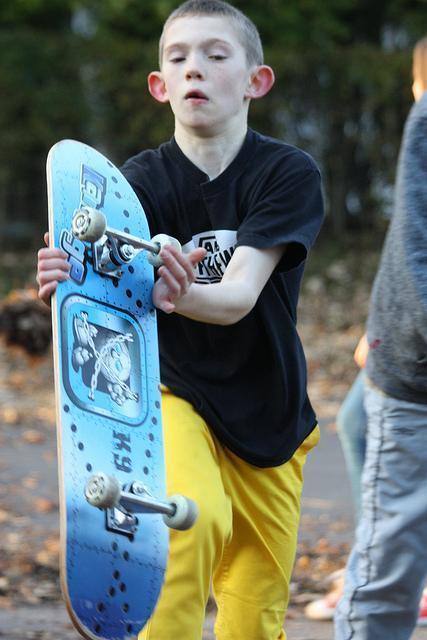What jungle animal do his ears resemble?
Choose the correct response and explain in the format: 'Answer: answer
Rationale: rationale.'
Options: Tiger, snake, monkey, parrot. Answer: monkey.
Rationale: Monkeys have really broad ears. 